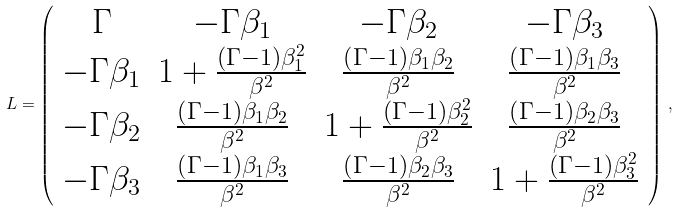Convert formula to latex. <formula><loc_0><loc_0><loc_500><loc_500>L = \left ( \begin{array} { c c c c } \Gamma & - \Gamma \beta _ { 1 } & - \Gamma \beta _ { 2 } & - \Gamma \beta _ { 3 } \\ - \Gamma \beta _ { 1 } & 1 + \frac { \left ( \Gamma - 1 \right ) \beta _ { 1 } ^ { 2 } } { \beta ^ { 2 } } & \frac { \left ( \Gamma - 1 \right ) \beta _ { 1 } \beta _ { 2 } } { \beta ^ { 2 } } & \frac { \left ( \Gamma - 1 \right ) \beta _ { 1 } \beta _ { 3 } } { \beta ^ { 2 } } \\ - \Gamma \beta _ { 2 } & \frac { \left ( \Gamma - 1 \right ) \beta _ { 1 } \beta _ { 2 } } { \beta ^ { 2 } } & 1 + \frac { \left ( \Gamma - 1 \right ) \beta _ { 2 } ^ { 2 } } { \beta ^ { 2 } } & \frac { \left ( \Gamma - 1 \right ) \beta _ { 2 } \beta _ { 3 } } { \beta ^ { 2 } } \\ - \Gamma \beta _ { 3 } & \frac { \left ( \Gamma - 1 \right ) \beta _ { 1 } \beta _ { 3 } } { \beta ^ { 2 } } & \frac { \left ( \Gamma - 1 \right ) \beta _ { 2 } \beta _ { 3 } } { \beta ^ { 2 } } & 1 + \frac { \left ( \Gamma - 1 \right ) \beta _ { 3 } ^ { 2 } } { \beta ^ { 2 } } \end{array} \right ) \, ,</formula> 